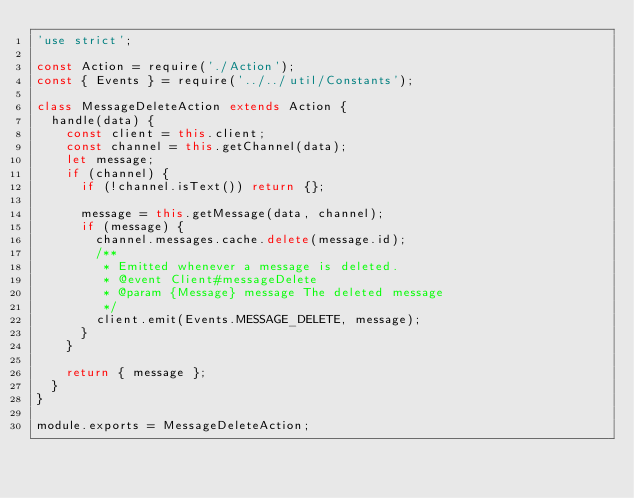<code> <loc_0><loc_0><loc_500><loc_500><_JavaScript_>'use strict';

const Action = require('./Action');
const { Events } = require('../../util/Constants');

class MessageDeleteAction extends Action {
  handle(data) {
    const client = this.client;
    const channel = this.getChannel(data);
    let message;
    if (channel) {
      if (!channel.isText()) return {};

      message = this.getMessage(data, channel);
      if (message) {
        channel.messages.cache.delete(message.id);
        /**
         * Emitted whenever a message is deleted.
         * @event Client#messageDelete
         * @param {Message} message The deleted message
         */
        client.emit(Events.MESSAGE_DELETE, message);
      }
    }

    return { message };
  }
}

module.exports = MessageDeleteAction;
</code> 